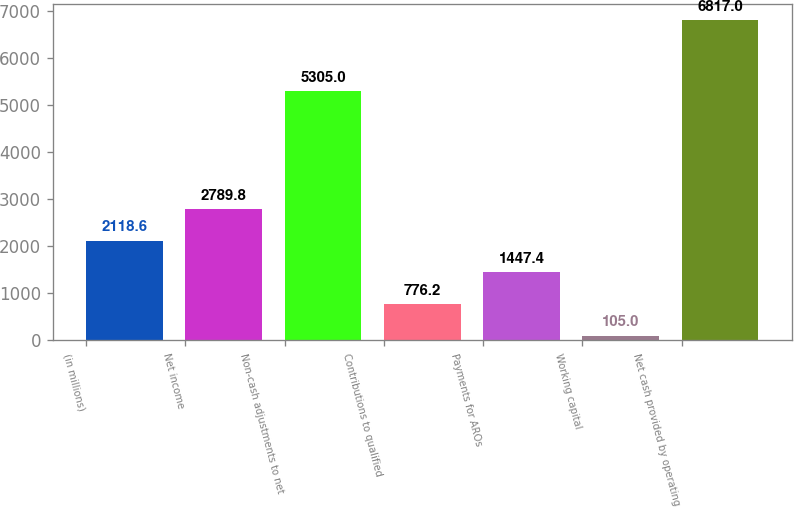Convert chart. <chart><loc_0><loc_0><loc_500><loc_500><bar_chart><fcel>(in millions)<fcel>Net income<fcel>Non-cash adjustments to net<fcel>Contributions to qualified<fcel>Payments for AROs<fcel>Working capital<fcel>Net cash provided by operating<nl><fcel>2118.6<fcel>2789.8<fcel>5305<fcel>776.2<fcel>1447.4<fcel>105<fcel>6817<nl></chart> 